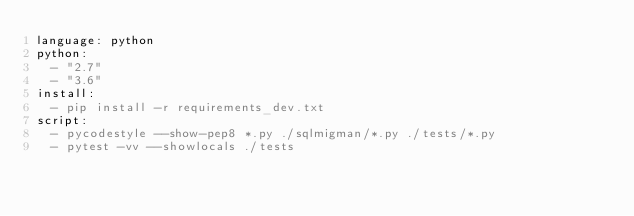<code> <loc_0><loc_0><loc_500><loc_500><_YAML_>language: python
python:
  - "2.7"
  - "3.6"
install:
  - pip install -r requirements_dev.txt
script:
  - pycodestyle --show-pep8 *.py ./sqlmigman/*.py ./tests/*.py
  - pytest -vv --showlocals ./tests
</code> 